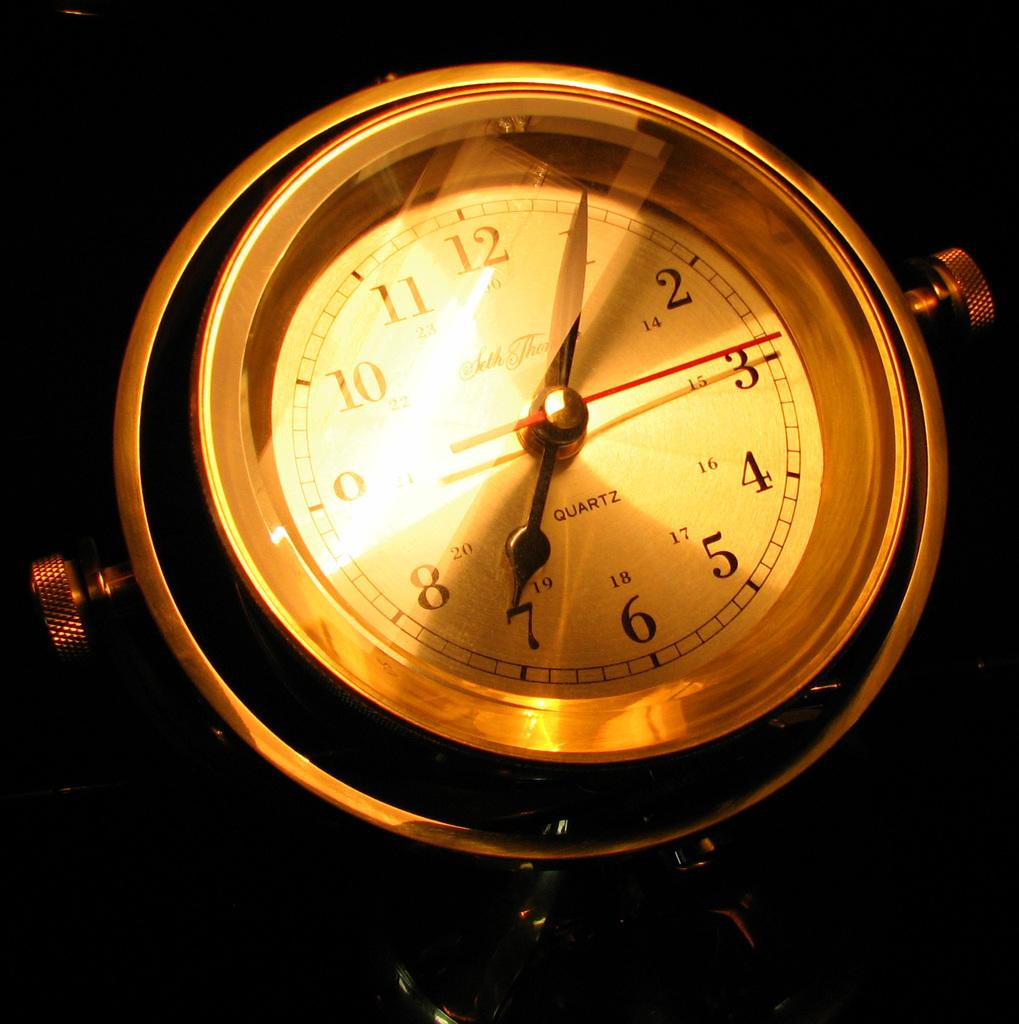<image>
Relay a brief, clear account of the picture shown. A quartz  clock with light reflecting off of it 